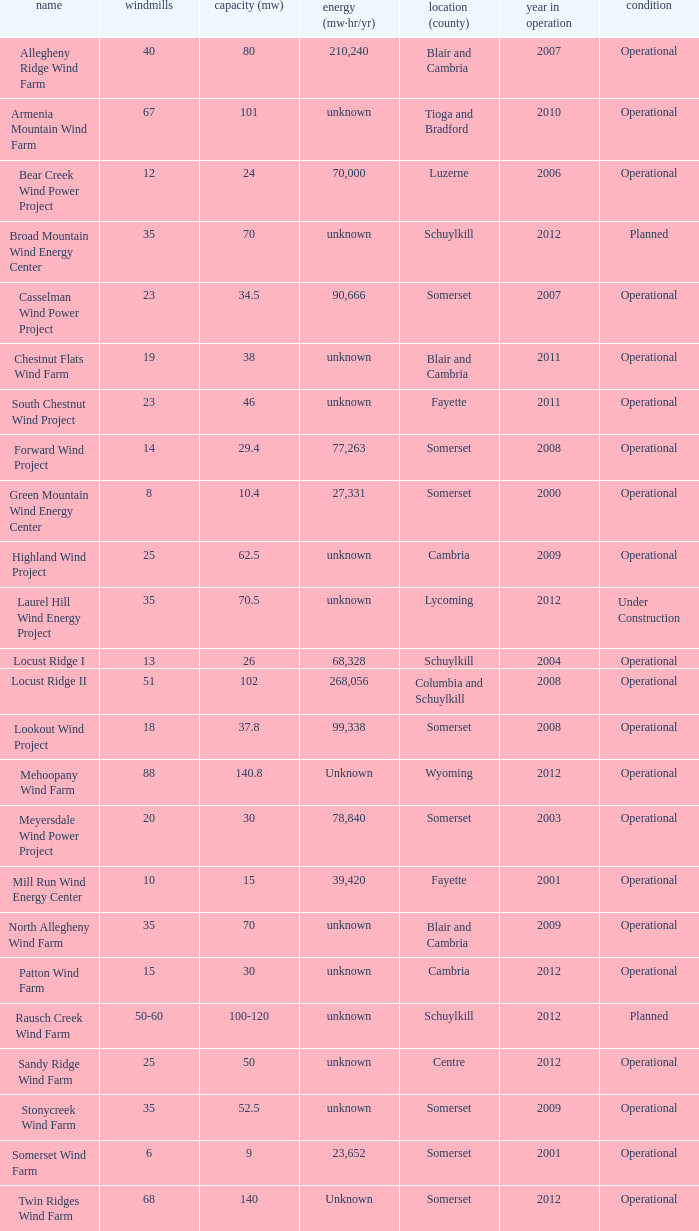What all capacities have turbines between 50-60? 100-120. Write the full table. {'header': ['name', 'windmills', 'capacity (mw)', 'energy (mw·hr/yr)', 'location (county)', 'year in operation', 'condition'], 'rows': [['Allegheny Ridge Wind Farm', '40', '80', '210,240', 'Blair and Cambria', '2007', 'Operational'], ['Armenia Mountain Wind Farm', '67', '101', 'unknown', 'Tioga and Bradford', '2010', 'Operational'], ['Bear Creek Wind Power Project', '12', '24', '70,000', 'Luzerne', '2006', 'Operational'], ['Broad Mountain Wind Energy Center', '35', '70', 'unknown', 'Schuylkill', '2012', 'Planned'], ['Casselman Wind Power Project', '23', '34.5', '90,666', 'Somerset', '2007', 'Operational'], ['Chestnut Flats Wind Farm', '19', '38', 'unknown', 'Blair and Cambria', '2011', 'Operational'], ['South Chestnut Wind Project', '23', '46', 'unknown', 'Fayette', '2011', 'Operational'], ['Forward Wind Project', '14', '29.4', '77,263', 'Somerset', '2008', 'Operational'], ['Green Mountain Wind Energy Center', '8', '10.4', '27,331', 'Somerset', '2000', 'Operational'], ['Highland Wind Project', '25', '62.5', 'unknown', 'Cambria', '2009', 'Operational'], ['Laurel Hill Wind Energy Project', '35', '70.5', 'unknown', 'Lycoming', '2012', 'Under Construction'], ['Locust Ridge I', '13', '26', '68,328', 'Schuylkill', '2004', 'Operational'], ['Locust Ridge II', '51', '102', '268,056', 'Columbia and Schuylkill', '2008', 'Operational'], ['Lookout Wind Project', '18', '37.8', '99,338', 'Somerset', '2008', 'Operational'], ['Mehoopany Wind Farm', '88', '140.8', 'Unknown', 'Wyoming', '2012', 'Operational'], ['Meyersdale Wind Power Project', '20', '30', '78,840', 'Somerset', '2003', 'Operational'], ['Mill Run Wind Energy Center', '10', '15', '39,420', 'Fayette', '2001', 'Operational'], ['North Allegheny Wind Farm', '35', '70', 'unknown', 'Blair and Cambria', '2009', 'Operational'], ['Patton Wind Farm', '15', '30', 'unknown', 'Cambria', '2012', 'Operational'], ['Rausch Creek Wind Farm', '50-60', '100-120', 'unknown', 'Schuylkill', '2012', 'Planned'], ['Sandy Ridge Wind Farm', '25', '50', 'unknown', 'Centre', '2012', 'Operational'], ['Stonycreek Wind Farm', '35', '52.5', 'unknown', 'Somerset', '2009', 'Operational'], ['Somerset Wind Farm', '6', '9', '23,652', 'Somerset', '2001', 'Operational'], ['Twin Ridges Wind Farm', '68', '140', 'Unknown', 'Somerset', '2012', 'Operational']]} 